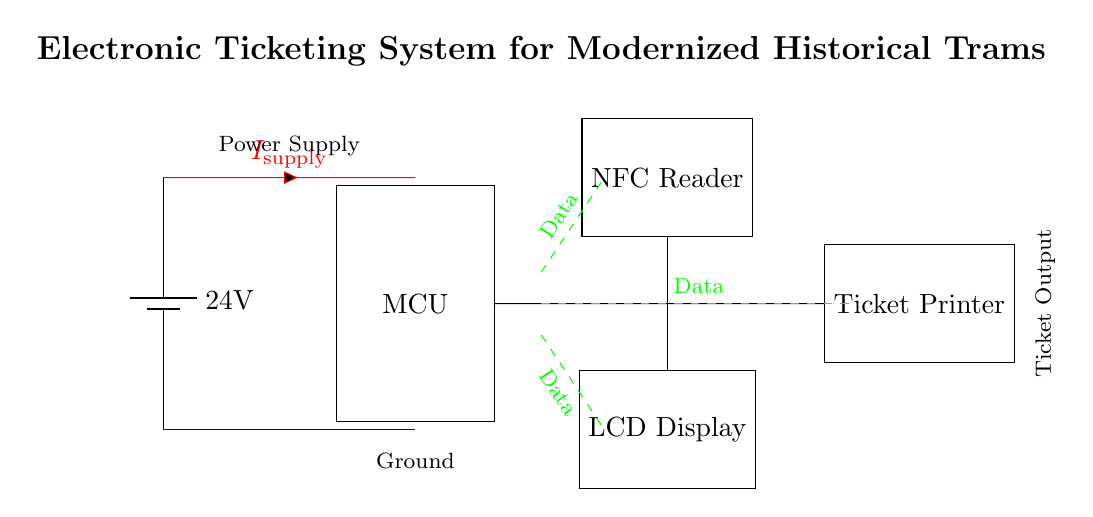What is the voltage of the power supply? The voltage of the power supply is specified as 24V, which is indicated on the battery component in the circuit diagram.
Answer: 24V What type of components are shown in the circuit diagram? The circuit diagram includes a microcontroller, an NFC reader, an LCD display, and a ticket printer, which are all represented as rectangular blocks in the diagram.
Answer: Microcontroller, NFC Reader, LCD Display, Ticket Printer What current flows into the circuit from the power supply? The current from the power supply is labeled as I_supply, which is shown in red along the connection line from the power supply to the microcontroller.
Answer: I_supply Which components are used to display information? The components that are meant to display information in the circuit are the LCD Display and the NFC Reader, which are responsible for visual output and interaction, respectively.
Answer: LCD Display, NFC Reader How are data connections represented in the circuit? The data connections are depicted as green dashed lines connecting the microcontroller to the NFC reader, LCD display, and ticket printer, indicating the flow of data between these components.
Answer: Green dashed lines What is the purpose of the ticket printer in this circuit? The ticket printer's purpose in this circuit is to produce physical tickets after processing data from the microcontroller, including the information collected from the NFC reader.
Answer: To produce tickets What additional electrical connections are indicated with the blue line? The blue line represents the ground connections in the circuit, showing the common reference point for all components to ensure proper operation and safety in electrical systems.
Answer: Ground connections 